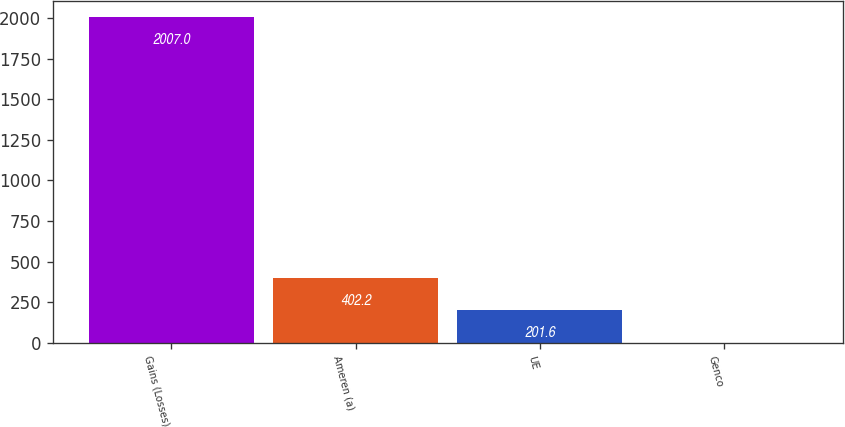Convert chart to OTSL. <chart><loc_0><loc_0><loc_500><loc_500><bar_chart><fcel>Gains (Losses)<fcel>Ameren (a)<fcel>UE<fcel>Genco<nl><fcel>2007<fcel>402.2<fcel>201.6<fcel>1<nl></chart> 